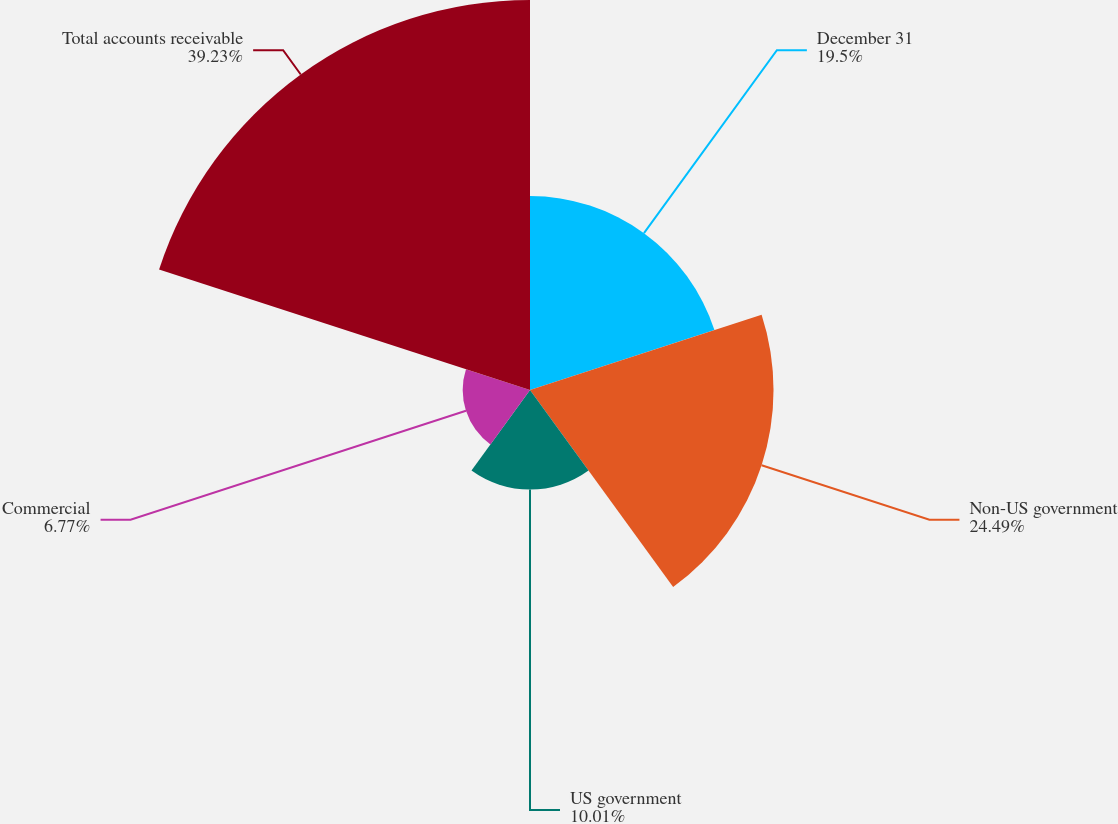Convert chart to OTSL. <chart><loc_0><loc_0><loc_500><loc_500><pie_chart><fcel>December 31<fcel>Non-US government<fcel>US government<fcel>Commercial<fcel>Total accounts receivable<nl><fcel>19.5%<fcel>24.49%<fcel>10.01%<fcel>6.77%<fcel>39.22%<nl></chart> 